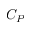Convert formula to latex. <formula><loc_0><loc_0><loc_500><loc_500>C _ { P }</formula> 